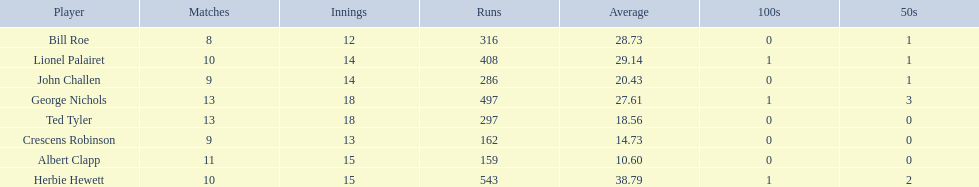Which players played in 10 or fewer matches? Herbie Hewett, Lionel Palairet, Bill Roe, John Challen, Crescens Robinson. Of these, which played in only 12 innings? Bill Roe. 